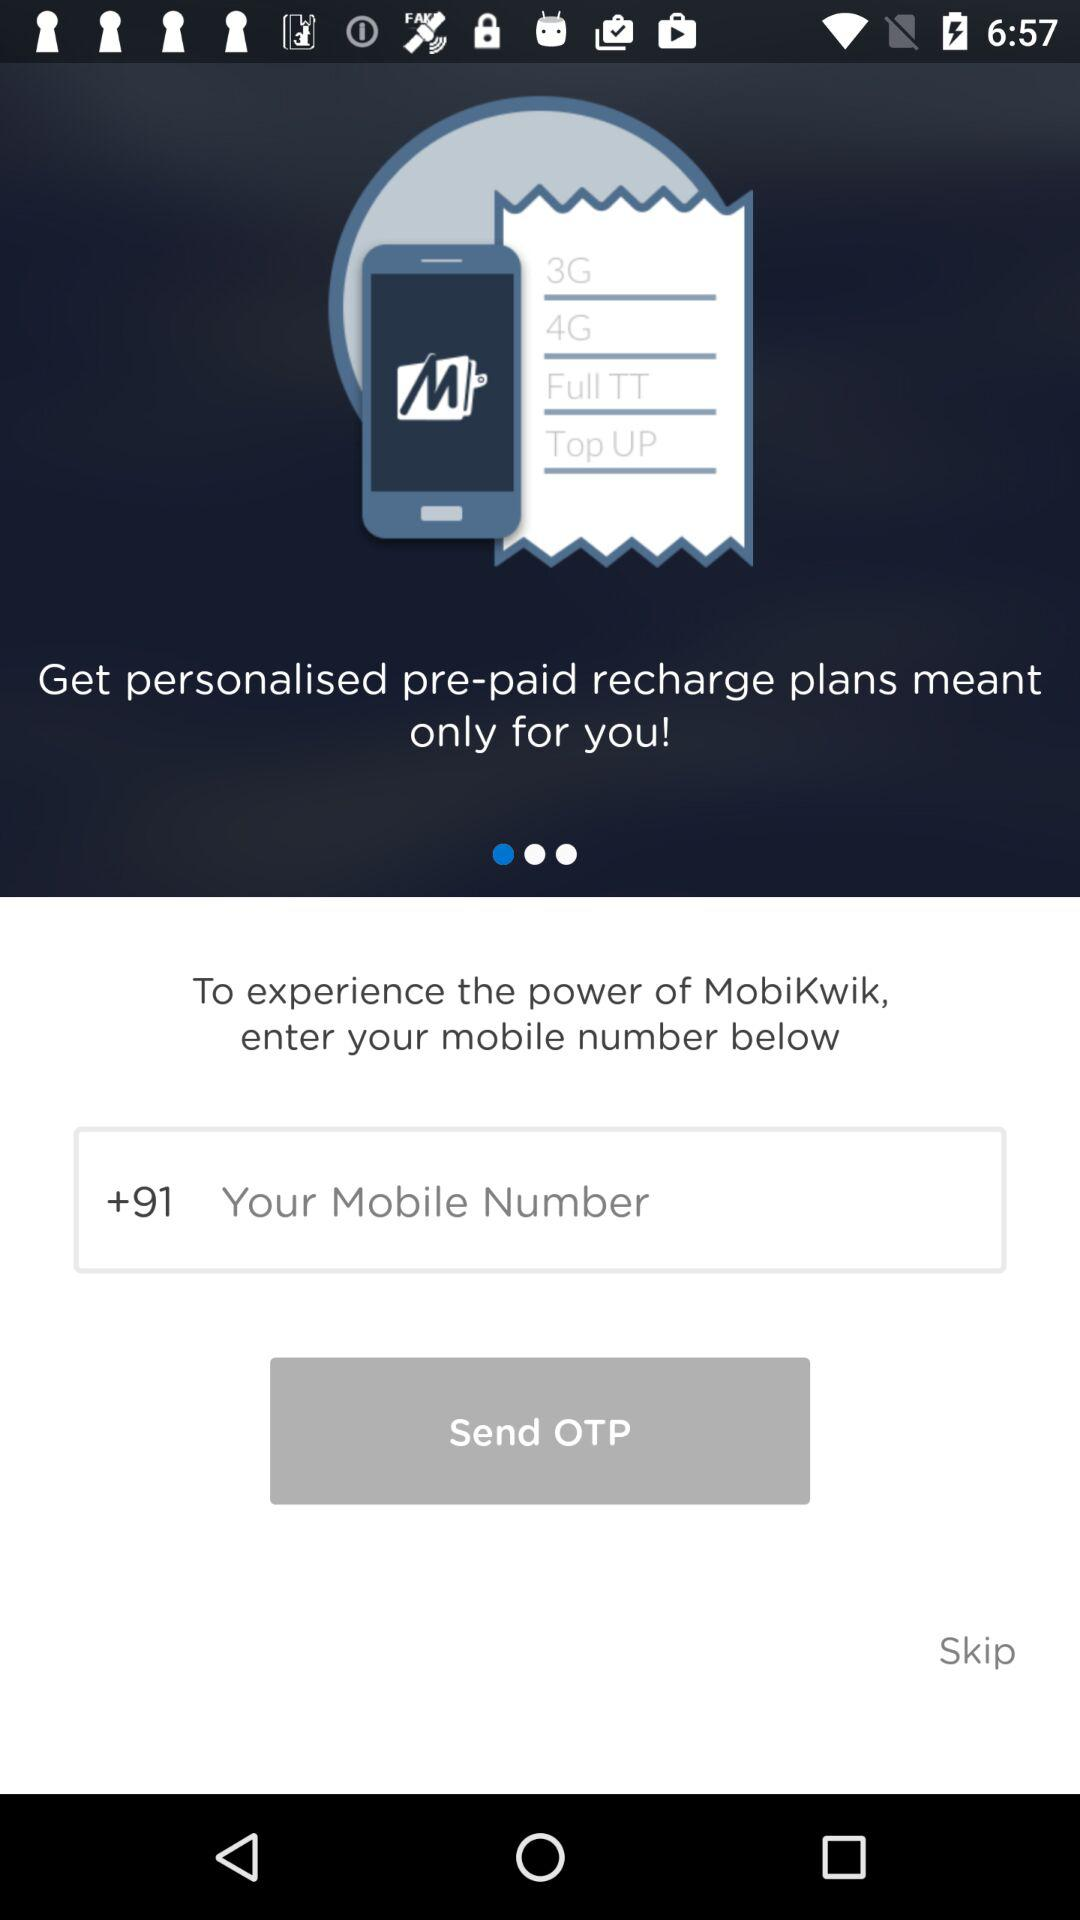What is required to experience the power of "MobiKwik"? A mobile number is required to experience the power of "MobiKwik". 